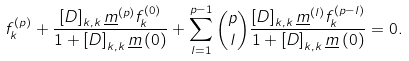<formula> <loc_0><loc_0><loc_500><loc_500>f ^ { \left ( p \right ) } _ { k } + \frac { \left [ D \right ] _ { k , k } \underline { m } ^ { \left ( p \right ) } f ^ { \left ( 0 \right ) } _ { k } } { 1 + \left [ D \right ] _ { k , k } \underline { m } \left ( 0 \right ) } + \sum _ { l = 1 } ^ { p - 1 } \binom { p } { l } \frac { \left [ D \right ] _ { k , k } \underline { m } ^ { \left ( l \right ) } f ^ { \left ( p - l \right ) } _ { k } } { 1 + \left [ D \right ] _ { k , k } \underline { m } \left ( 0 \right ) } = 0 .</formula> 